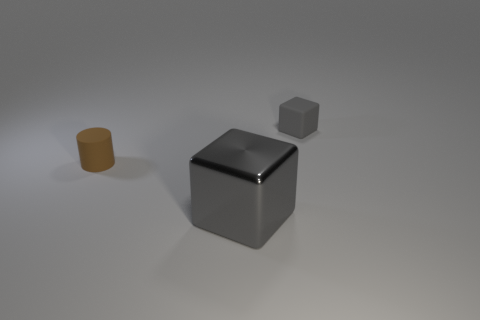Add 1 big purple shiny cylinders. How many objects exist? 4 Subtract 1 cubes. How many cubes are left? 1 Add 3 big gray things. How many big gray things exist? 4 Subtract 0 blue balls. How many objects are left? 3 Subtract all blocks. How many objects are left? 1 Subtract all yellow cubes. Subtract all red spheres. How many cubes are left? 2 Subtract all shiny blocks. Subtract all yellow rubber cylinders. How many objects are left? 2 Add 3 big cubes. How many big cubes are left? 4 